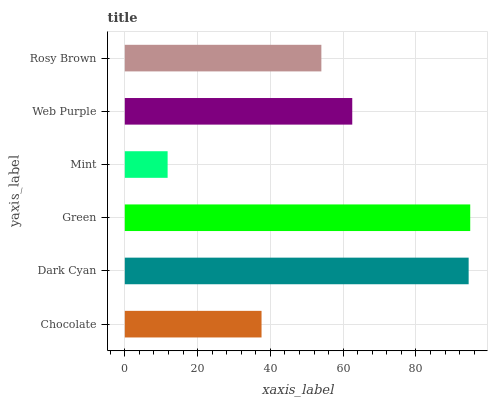Is Mint the minimum?
Answer yes or no. Yes. Is Green the maximum?
Answer yes or no. Yes. Is Dark Cyan the minimum?
Answer yes or no. No. Is Dark Cyan the maximum?
Answer yes or no. No. Is Dark Cyan greater than Chocolate?
Answer yes or no. Yes. Is Chocolate less than Dark Cyan?
Answer yes or no. Yes. Is Chocolate greater than Dark Cyan?
Answer yes or no. No. Is Dark Cyan less than Chocolate?
Answer yes or no. No. Is Web Purple the high median?
Answer yes or no. Yes. Is Rosy Brown the low median?
Answer yes or no. Yes. Is Mint the high median?
Answer yes or no. No. Is Web Purple the low median?
Answer yes or no. No. 